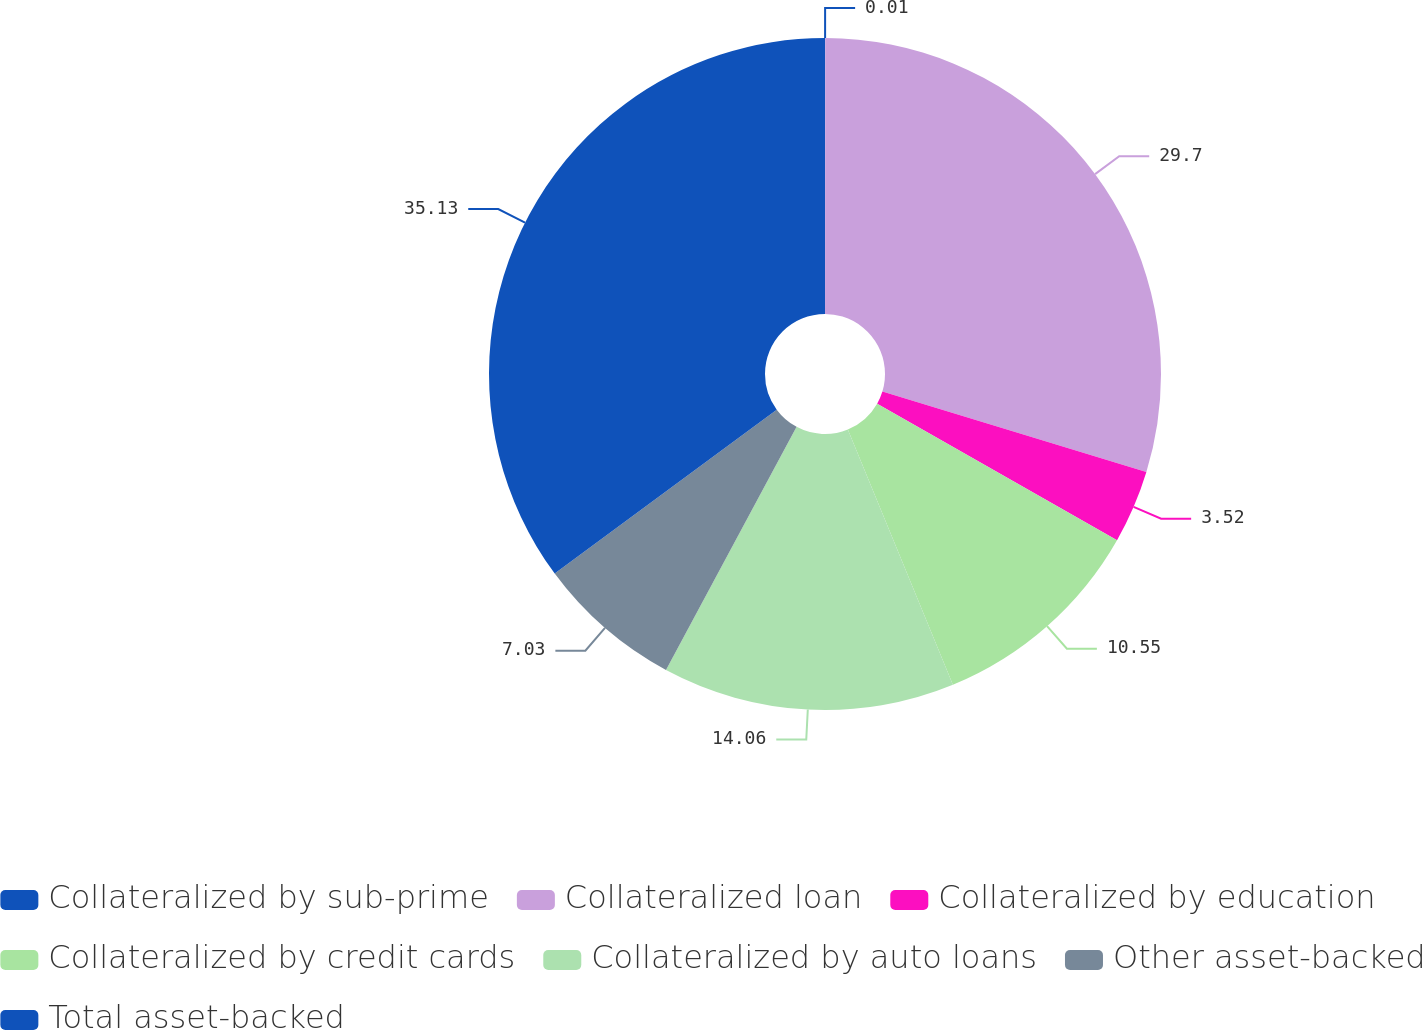Convert chart. <chart><loc_0><loc_0><loc_500><loc_500><pie_chart><fcel>Collateralized by sub-prime<fcel>Collateralized loan<fcel>Collateralized by education<fcel>Collateralized by credit cards<fcel>Collateralized by auto loans<fcel>Other asset-backed<fcel>Total asset-backed<nl><fcel>0.01%<fcel>29.7%<fcel>3.52%<fcel>10.55%<fcel>14.06%<fcel>7.03%<fcel>35.12%<nl></chart> 